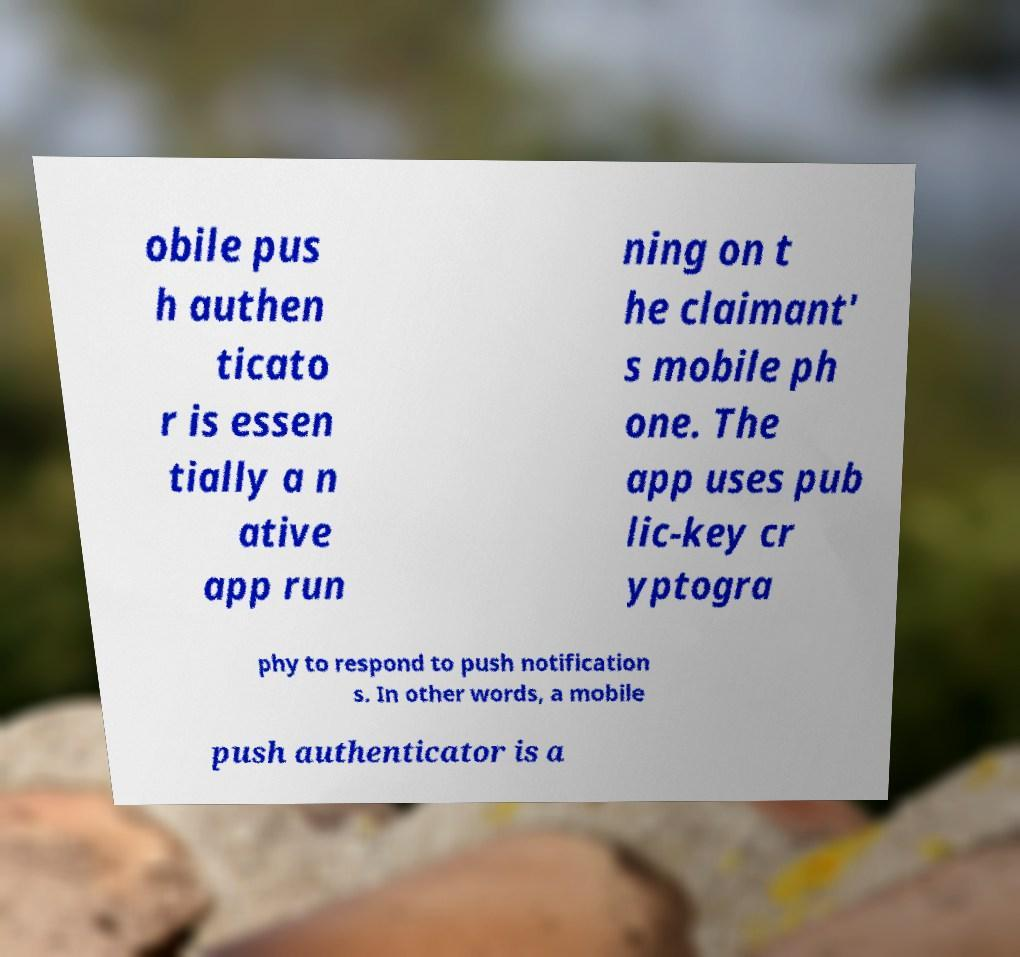I need the written content from this picture converted into text. Can you do that? obile pus h authen ticato r is essen tially a n ative app run ning on t he claimant' s mobile ph one. The app uses pub lic-key cr yptogra phy to respond to push notification s. In other words, a mobile push authenticator is a 